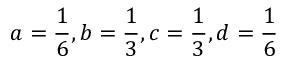<formula> <loc_0><loc_0><loc_500><loc_500>a = { \frac { 1 } { 6 } } , b = { \frac { 1 } { 3 } } , c = { \frac { 1 } { 3 } } , d = { \frac { 1 } { 6 } }</formula> 